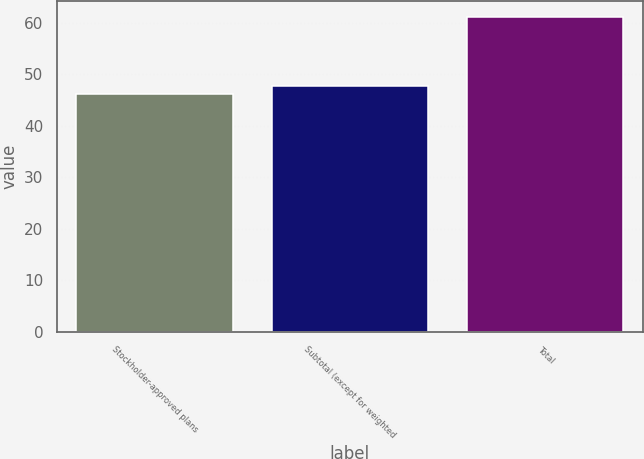<chart> <loc_0><loc_0><loc_500><loc_500><bar_chart><fcel>Stockholder-approved plans<fcel>Subtotal (except for weighted<fcel>Total<nl><fcel>46.2<fcel>47.7<fcel>61.2<nl></chart> 